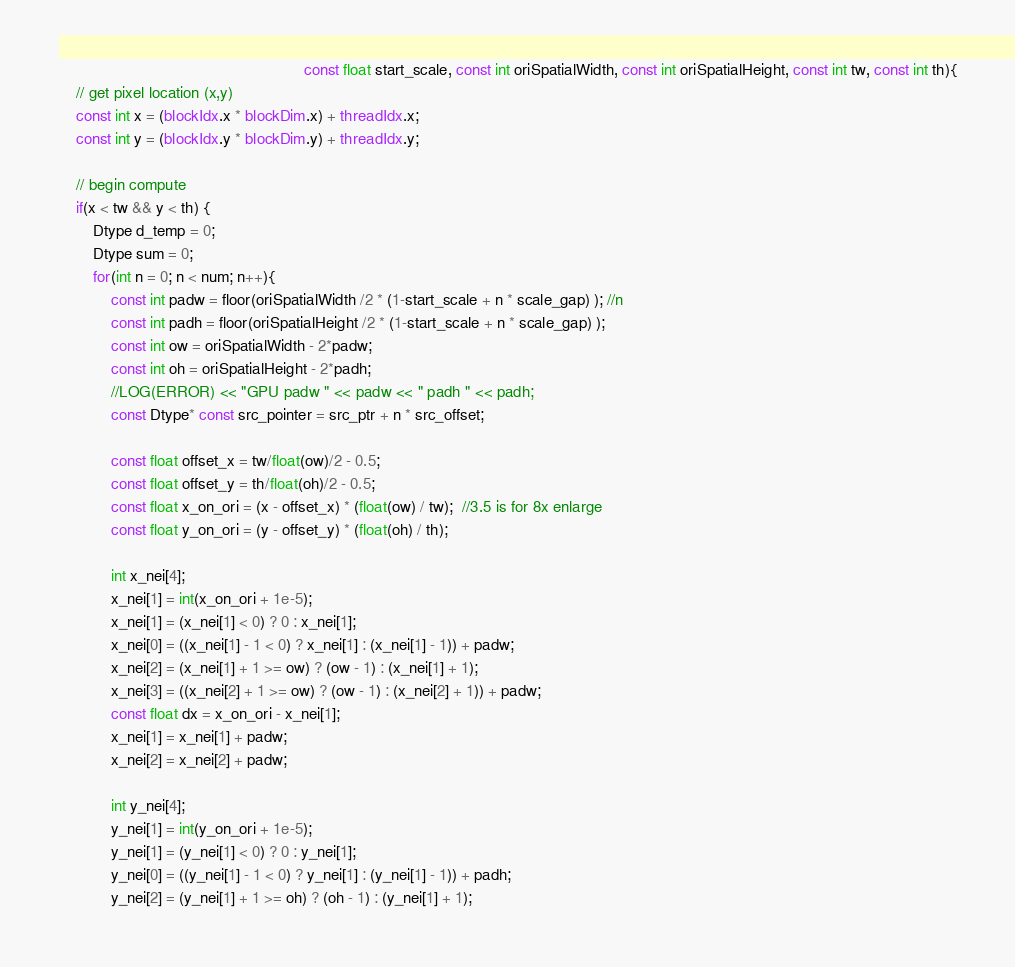<code> <loc_0><loc_0><loc_500><loc_500><_Cuda_>									                    const float start_scale, const int oriSpatialWidth, const int oriSpatialHeight, const int tw, const int th){
	// get pixel location (x,y)
	const int x = (blockIdx.x * blockDim.x) + threadIdx.x;
	const int y = (blockIdx.y * blockDim.y) + threadIdx.y;

	// begin compute
	if(x < tw && y < th) {
		Dtype d_temp = 0;
		Dtype sum = 0;
		for(int n = 0; n < num; n++){
			const int padw = floor(oriSpatialWidth /2 * (1-start_scale + n * scale_gap) ); //n
			const int padh = floor(oriSpatialHeight /2 * (1-start_scale + n * scale_gap) );
			const int ow = oriSpatialWidth - 2*padw;
			const int oh = oriSpatialHeight - 2*padh;
			//LOG(ERROR) << "GPU padw " << padw << " padh " << padh;
			const Dtype* const src_pointer = src_ptr + n * src_offset;

			const float offset_x = tw/float(ow)/2 - 0.5;
			const float offset_y = th/float(oh)/2 - 0.5;
			const float x_on_ori = (x - offset_x) * (float(ow) / tw);  //3.5 is for 8x enlarge
			const float y_on_ori = (y - offset_y) * (float(oh) / th);

			int x_nei[4];
			x_nei[1] = int(x_on_ori + 1e-5);
			x_nei[1] = (x_nei[1] < 0) ? 0 : x_nei[1];
			x_nei[0] = ((x_nei[1] - 1 < 0) ? x_nei[1] : (x_nei[1] - 1)) + padw;
			x_nei[2] = (x_nei[1] + 1 >= ow) ? (ow - 1) : (x_nei[1] + 1);
			x_nei[3] = ((x_nei[2] + 1 >= ow) ? (ow - 1) : (x_nei[2] + 1)) + padw;
			const float dx = x_on_ori - x_nei[1];
			x_nei[1] = x_nei[1] + padw;
			x_nei[2] = x_nei[2] + padw;

			int y_nei[4];
			y_nei[1] = int(y_on_ori + 1e-5);
			y_nei[1] = (y_nei[1] < 0) ? 0 : y_nei[1];
			y_nei[0] = ((y_nei[1] - 1 < 0) ? y_nei[1] : (y_nei[1] - 1)) + padh;
			y_nei[2] = (y_nei[1] + 1 >= oh) ? (oh - 1) : (y_nei[1] + 1);</code> 